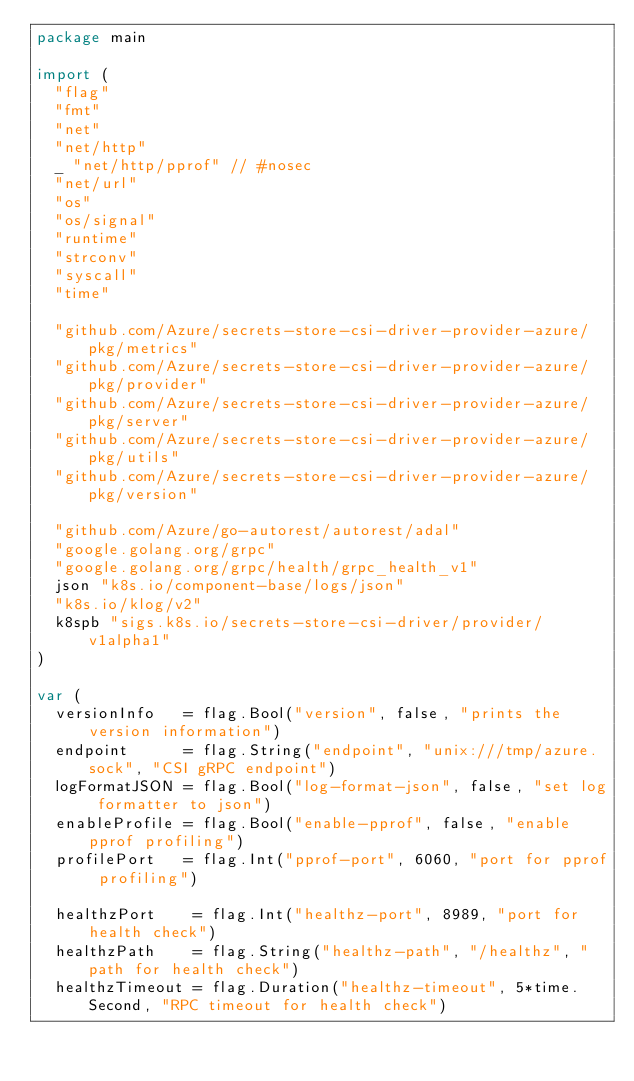<code> <loc_0><loc_0><loc_500><loc_500><_Go_>package main

import (
	"flag"
	"fmt"
	"net"
	"net/http"
	_ "net/http/pprof" // #nosec
	"net/url"
	"os"
	"os/signal"
	"runtime"
	"strconv"
	"syscall"
	"time"

	"github.com/Azure/secrets-store-csi-driver-provider-azure/pkg/metrics"
	"github.com/Azure/secrets-store-csi-driver-provider-azure/pkg/provider"
	"github.com/Azure/secrets-store-csi-driver-provider-azure/pkg/server"
	"github.com/Azure/secrets-store-csi-driver-provider-azure/pkg/utils"
	"github.com/Azure/secrets-store-csi-driver-provider-azure/pkg/version"

	"github.com/Azure/go-autorest/autorest/adal"
	"google.golang.org/grpc"
	"google.golang.org/grpc/health/grpc_health_v1"
	json "k8s.io/component-base/logs/json"
	"k8s.io/klog/v2"
	k8spb "sigs.k8s.io/secrets-store-csi-driver/provider/v1alpha1"
)

var (
	versionInfo   = flag.Bool("version", false, "prints the version information")
	endpoint      = flag.String("endpoint", "unix:///tmp/azure.sock", "CSI gRPC endpoint")
	logFormatJSON = flag.Bool("log-format-json", false, "set log formatter to json")
	enableProfile = flag.Bool("enable-pprof", false, "enable pprof profiling")
	profilePort   = flag.Int("pprof-port", 6060, "port for pprof profiling")

	healthzPort    = flag.Int("healthz-port", 8989, "port for health check")
	healthzPath    = flag.String("healthz-path", "/healthz", "path for health check")
	healthzTimeout = flag.Duration("healthz-timeout", 5*time.Second, "RPC timeout for health check")
</code> 